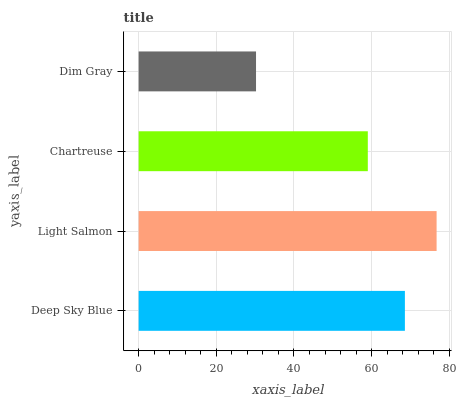Is Dim Gray the minimum?
Answer yes or no. Yes. Is Light Salmon the maximum?
Answer yes or no. Yes. Is Chartreuse the minimum?
Answer yes or no. No. Is Chartreuse the maximum?
Answer yes or no. No. Is Light Salmon greater than Chartreuse?
Answer yes or no. Yes. Is Chartreuse less than Light Salmon?
Answer yes or no. Yes. Is Chartreuse greater than Light Salmon?
Answer yes or no. No. Is Light Salmon less than Chartreuse?
Answer yes or no. No. Is Deep Sky Blue the high median?
Answer yes or no. Yes. Is Chartreuse the low median?
Answer yes or no. Yes. Is Dim Gray the high median?
Answer yes or no. No. Is Deep Sky Blue the low median?
Answer yes or no. No. 